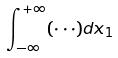<formula> <loc_0><loc_0><loc_500><loc_500>\int _ { - \infty } ^ { + \infty } ( \cdot \cdot \cdot ) d x _ { 1 }</formula> 